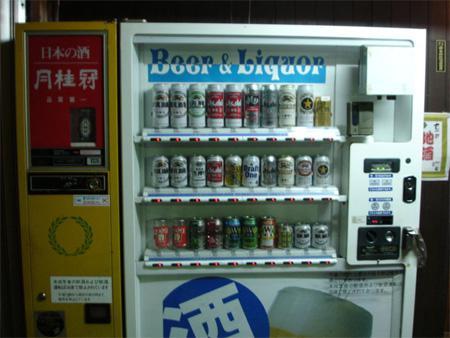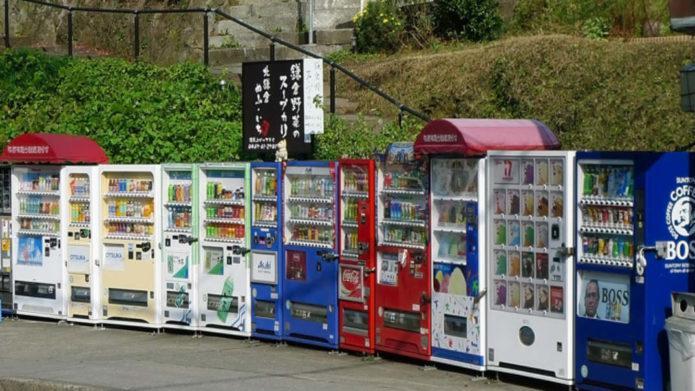The first image is the image on the left, the second image is the image on the right. For the images displayed, is the sentence "There are at least three vending machines that have blue casing." factually correct? Answer yes or no. Yes. The first image is the image on the left, the second image is the image on the right. For the images shown, is this caption "An image shows a row of red, white and blue vending machines." true? Answer yes or no. Yes. 